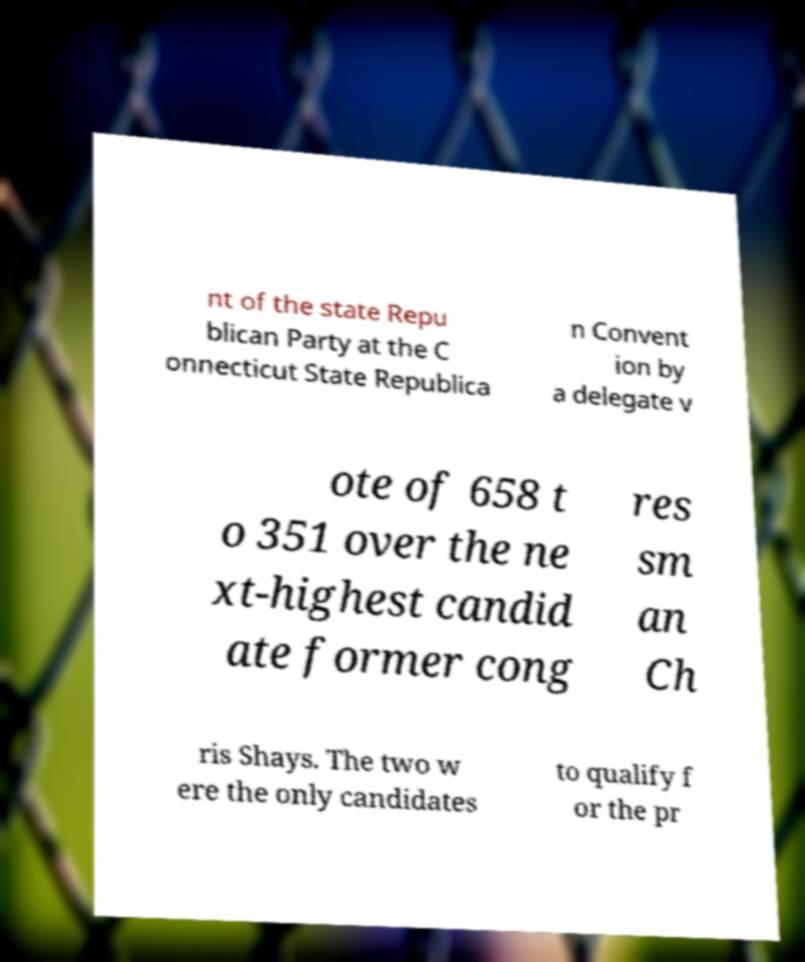For documentation purposes, I need the text within this image transcribed. Could you provide that? nt of the state Repu blican Party at the C onnecticut State Republica n Convent ion by a delegate v ote of 658 t o 351 over the ne xt-highest candid ate former cong res sm an Ch ris Shays. The two w ere the only candidates to qualify f or the pr 